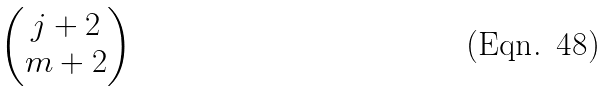Convert formula to latex. <formula><loc_0><loc_0><loc_500><loc_500>\begin{pmatrix} j + 2 \\ m + 2 \end{pmatrix}</formula> 